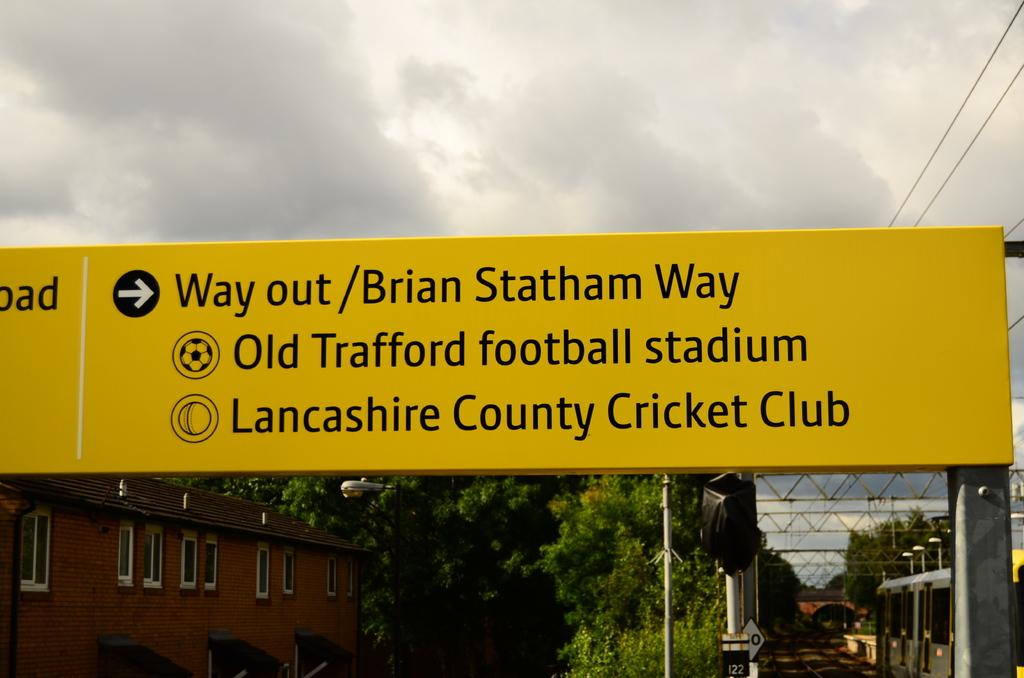What is the main object in the image with text on it? There is a yellow color board with text in the image. What type of structures can be seen in the image? There are buildings in the image. What type of vegetation is present in the image? There are trees in the image. What type of vertical structures are present in the image? There are poles in the image. What type of illumination is present in the image? There are lights in the image. What type of informational signs are present in the image? There are sign boards in the image. What can be seen in the background of the image? The sky is visible in the background of the image. How many pizzas are being served on the yellow color board in the image? There are no pizzas present on the yellow color board or in the image. 